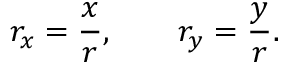<formula> <loc_0><loc_0><loc_500><loc_500>r _ { x } = \frac { x } { r } , \quad r _ { y } = \frac { y } { r } .</formula> 